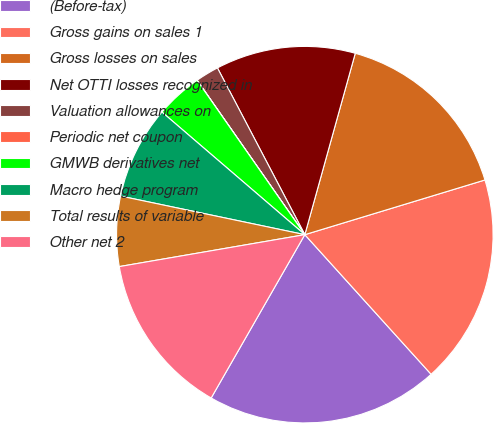<chart> <loc_0><loc_0><loc_500><loc_500><pie_chart><fcel>(Before-tax)<fcel>Gross gains on sales 1<fcel>Gross losses on sales<fcel>Net OTTI losses recognized in<fcel>Valuation allowances on<fcel>Periodic net coupon<fcel>GMWB derivatives net<fcel>Macro hedge program<fcel>Total results of variable<fcel>Other net 2<nl><fcel>19.99%<fcel>17.99%<fcel>15.99%<fcel>12.0%<fcel>2.01%<fcel>0.01%<fcel>4.01%<fcel>8.0%<fcel>6.0%<fcel>14.0%<nl></chart> 